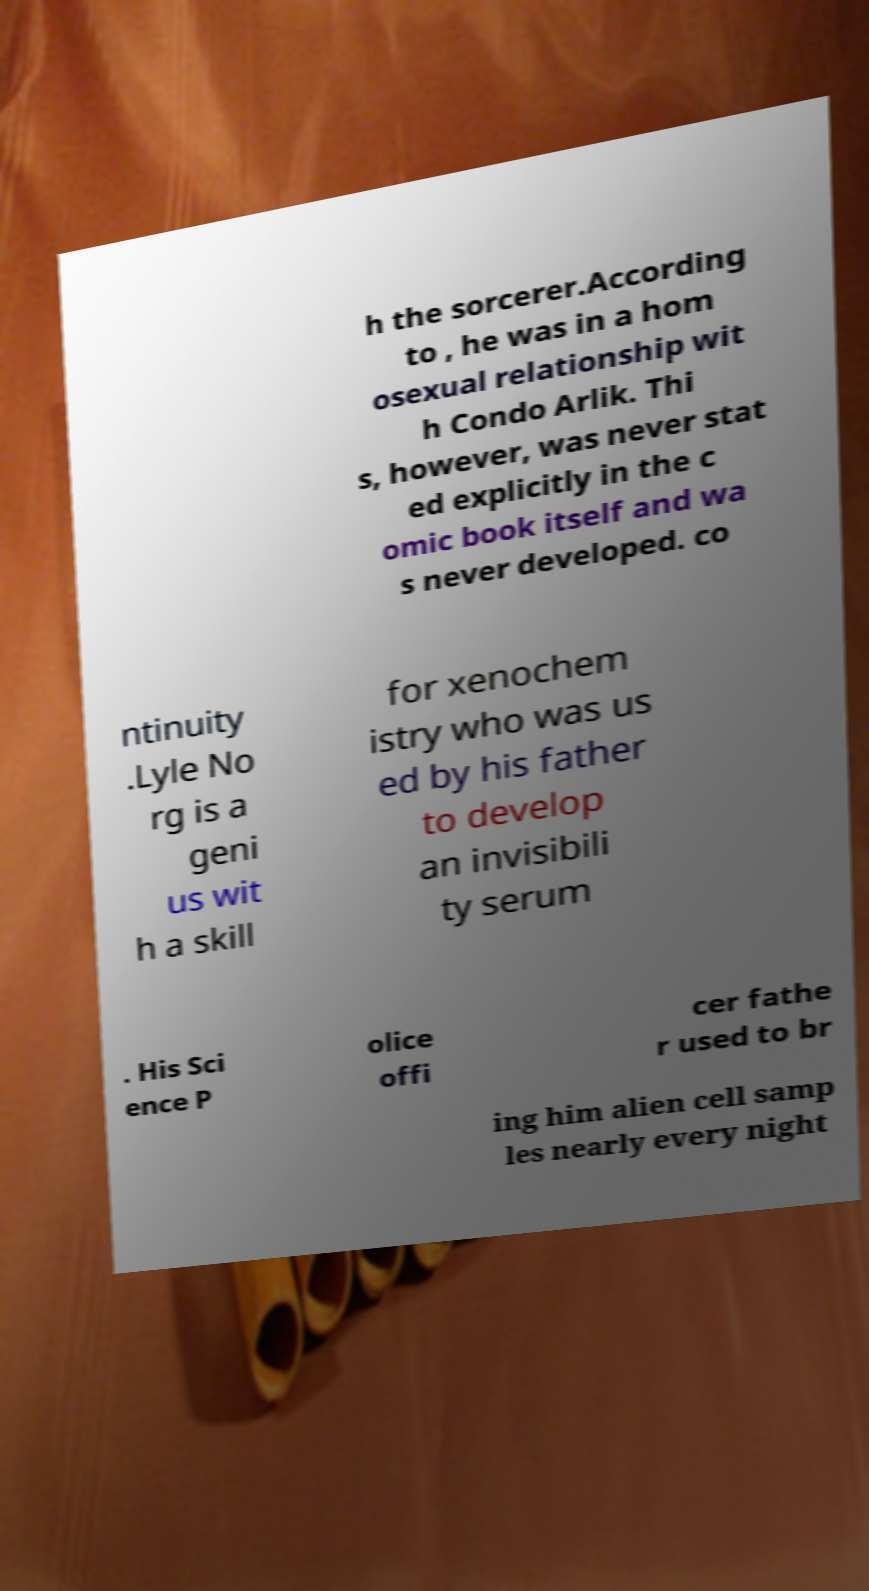Can you accurately transcribe the text from the provided image for me? h the sorcerer.According to , he was in a hom osexual relationship wit h Condo Arlik. Thi s, however, was never stat ed explicitly in the c omic book itself and wa s never developed. co ntinuity .Lyle No rg is a geni us wit h a skill for xenochem istry who was us ed by his father to develop an invisibili ty serum . His Sci ence P olice offi cer fathe r used to br ing him alien cell samp les nearly every night 